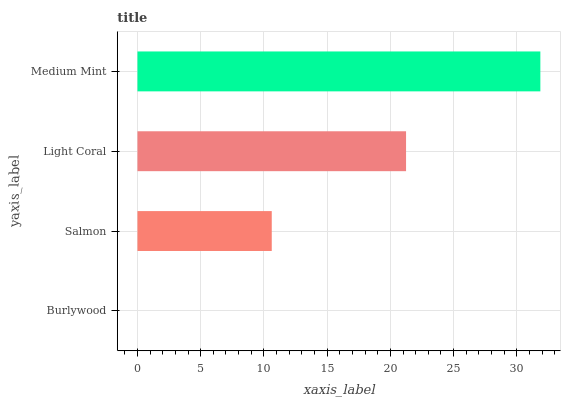Is Burlywood the minimum?
Answer yes or no. Yes. Is Medium Mint the maximum?
Answer yes or no. Yes. Is Salmon the minimum?
Answer yes or no. No. Is Salmon the maximum?
Answer yes or no. No. Is Salmon greater than Burlywood?
Answer yes or no. Yes. Is Burlywood less than Salmon?
Answer yes or no. Yes. Is Burlywood greater than Salmon?
Answer yes or no. No. Is Salmon less than Burlywood?
Answer yes or no. No. Is Light Coral the high median?
Answer yes or no. Yes. Is Salmon the low median?
Answer yes or no. Yes. Is Medium Mint the high median?
Answer yes or no. No. Is Burlywood the low median?
Answer yes or no. No. 